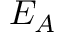<formula> <loc_0><loc_0><loc_500><loc_500>E _ { A }</formula> 